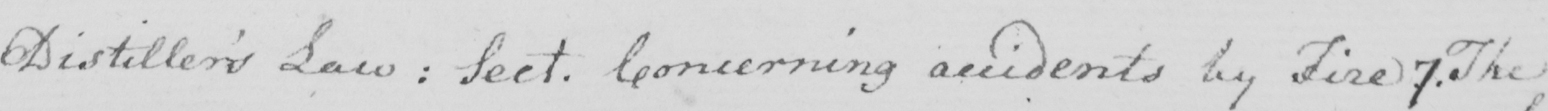What does this handwritten line say? Distiller ' s Law :  Sect . Concerning accidents by Fire 7 . The 